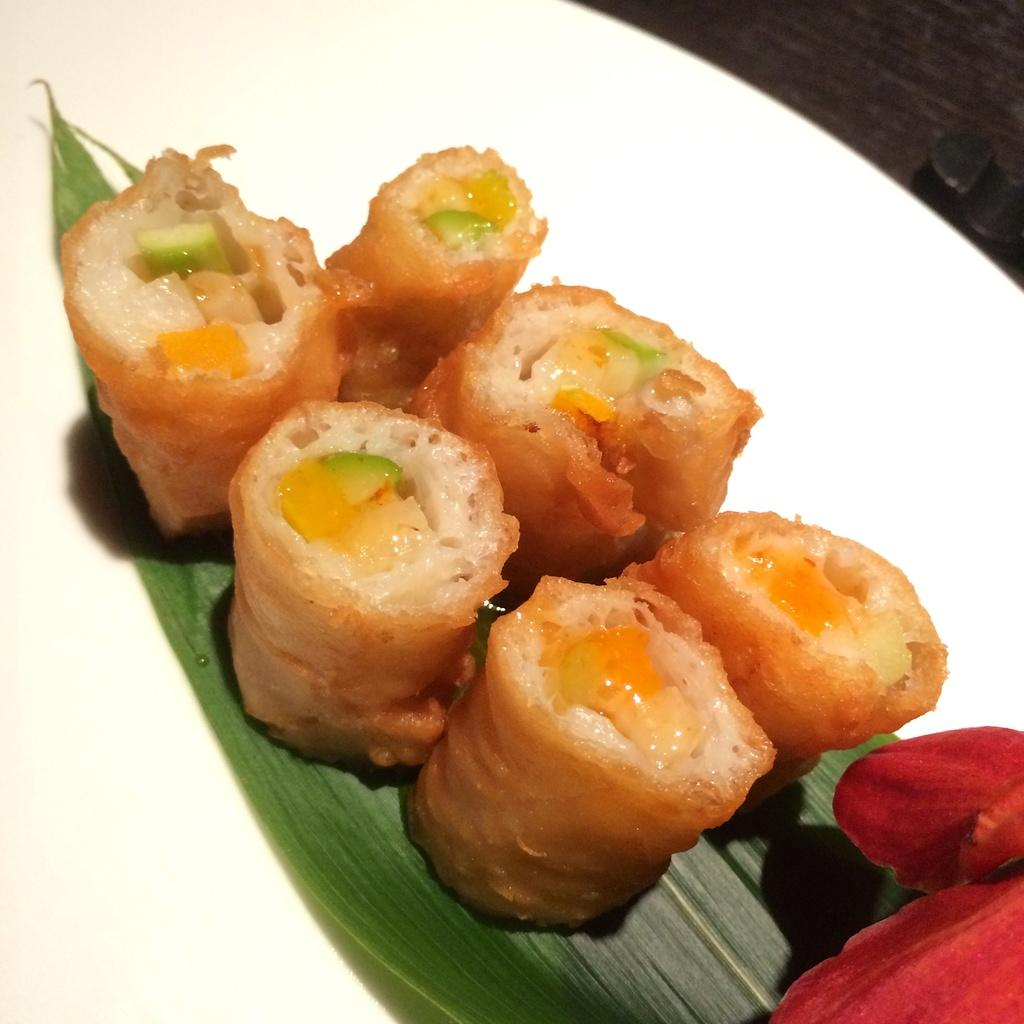What object can be seen in the picture? There is a plate in the picture. What is on the plate? There are food items on the plate. What type of calculator is visible on the plate? There is no calculator present on the plate; it only contains food items. How many cows can be seen grazing on the plate? There are no cows present on the plate; it only contains food items. 